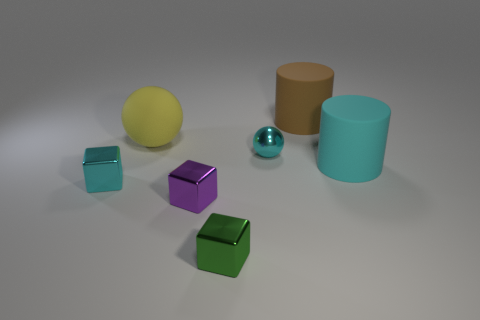Add 2 large red matte spheres. How many objects exist? 9 Subtract all purple blocks. How many blocks are left? 2 Subtract all tiny purple cubes. How many cubes are left? 2 Subtract 0 green spheres. How many objects are left? 7 Subtract all blocks. How many objects are left? 4 Subtract 3 cubes. How many cubes are left? 0 Subtract all yellow spheres. Subtract all gray cylinders. How many spheres are left? 1 Subtract all brown cubes. How many brown cylinders are left? 1 Subtract all red matte cylinders. Subtract all big brown cylinders. How many objects are left? 6 Add 1 large brown cylinders. How many large brown cylinders are left? 2 